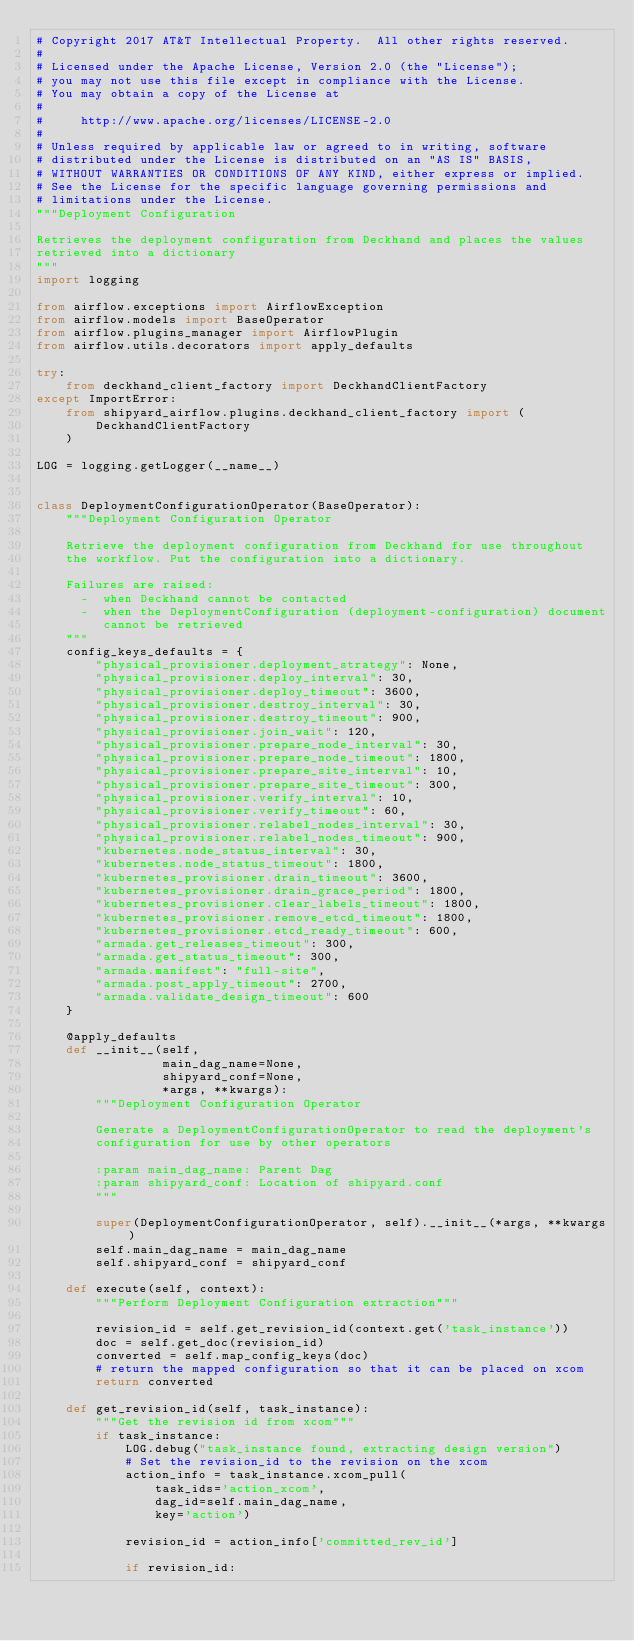Convert code to text. <code><loc_0><loc_0><loc_500><loc_500><_Python_># Copyright 2017 AT&T Intellectual Property.  All other rights reserved.
#
# Licensed under the Apache License, Version 2.0 (the "License");
# you may not use this file except in compliance with the License.
# You may obtain a copy of the License at
#
#     http://www.apache.org/licenses/LICENSE-2.0
#
# Unless required by applicable law or agreed to in writing, software
# distributed under the License is distributed on an "AS IS" BASIS,
# WITHOUT WARRANTIES OR CONDITIONS OF ANY KIND, either express or implied.
# See the License for the specific language governing permissions and
# limitations under the License.
"""Deployment Configuration

Retrieves the deployment configuration from Deckhand and places the values
retrieved into a dictionary
"""
import logging

from airflow.exceptions import AirflowException
from airflow.models import BaseOperator
from airflow.plugins_manager import AirflowPlugin
from airflow.utils.decorators import apply_defaults

try:
    from deckhand_client_factory import DeckhandClientFactory
except ImportError:
    from shipyard_airflow.plugins.deckhand_client_factory import (
        DeckhandClientFactory
    )

LOG = logging.getLogger(__name__)


class DeploymentConfigurationOperator(BaseOperator):
    """Deployment Configuration Operator

    Retrieve the deployment configuration from Deckhand for use throughout
    the workflow. Put the configuration into a dictionary.

    Failures are raised:
      -  when Deckhand cannot be contacted
      -  when the DeploymentConfiguration (deployment-configuration) document
         cannot be retrieved
    """
    config_keys_defaults = {
        "physical_provisioner.deployment_strategy": None,
        "physical_provisioner.deploy_interval": 30,
        "physical_provisioner.deploy_timeout": 3600,
        "physical_provisioner.destroy_interval": 30,
        "physical_provisioner.destroy_timeout": 900,
        "physical_provisioner.join_wait": 120,
        "physical_provisioner.prepare_node_interval": 30,
        "physical_provisioner.prepare_node_timeout": 1800,
        "physical_provisioner.prepare_site_interval": 10,
        "physical_provisioner.prepare_site_timeout": 300,
        "physical_provisioner.verify_interval": 10,
        "physical_provisioner.verify_timeout": 60,
        "physical_provisioner.relabel_nodes_interval": 30,
        "physical_provisioner.relabel_nodes_timeout": 900,
        "kubernetes.node_status_interval": 30,
        "kubernetes.node_status_timeout": 1800,
        "kubernetes_provisioner.drain_timeout": 3600,
        "kubernetes_provisioner.drain_grace_period": 1800,
        "kubernetes_provisioner.clear_labels_timeout": 1800,
        "kubernetes_provisioner.remove_etcd_timeout": 1800,
        "kubernetes_provisioner.etcd_ready_timeout": 600,
        "armada.get_releases_timeout": 300,
        "armada.get_status_timeout": 300,
        "armada.manifest": "full-site",
        "armada.post_apply_timeout": 2700,
        "armada.validate_design_timeout": 600
    }

    @apply_defaults
    def __init__(self,
                 main_dag_name=None,
                 shipyard_conf=None,
                 *args, **kwargs):
        """Deployment Configuration Operator

        Generate a DeploymentConfigurationOperator to read the deployment's
        configuration for use by other operators

        :param main_dag_name: Parent Dag
        :param shipyard_conf: Location of shipyard.conf
        """

        super(DeploymentConfigurationOperator, self).__init__(*args, **kwargs)
        self.main_dag_name = main_dag_name
        self.shipyard_conf = shipyard_conf

    def execute(self, context):
        """Perform Deployment Configuration extraction"""

        revision_id = self.get_revision_id(context.get('task_instance'))
        doc = self.get_doc(revision_id)
        converted = self.map_config_keys(doc)
        # return the mapped configuration so that it can be placed on xcom
        return converted

    def get_revision_id(self, task_instance):
        """Get the revision id from xcom"""
        if task_instance:
            LOG.debug("task_instance found, extracting design version")
            # Set the revision_id to the revision on the xcom
            action_info = task_instance.xcom_pull(
                task_ids='action_xcom',
                dag_id=self.main_dag_name,
                key='action')

            revision_id = action_info['committed_rev_id']

            if revision_id:</code> 